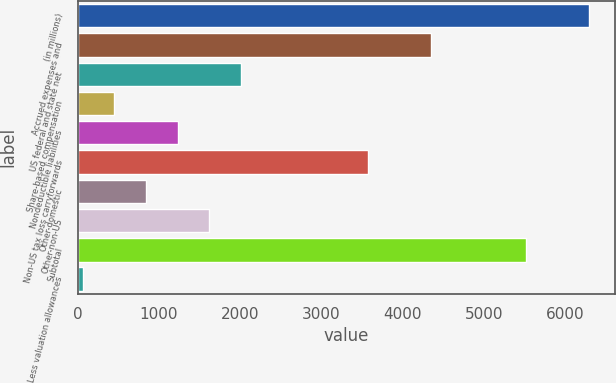Convert chart to OTSL. <chart><loc_0><loc_0><loc_500><loc_500><bar_chart><fcel>(in millions)<fcel>Accrued expenses and<fcel>US federal and state net<fcel>Share-based compensation<fcel>Nondeductible liabilities<fcel>Non-US tax loss carryforwards<fcel>Other-domestic<fcel>Other-non-US<fcel>Subtotal<fcel>Less valuation allowances<nl><fcel>6288<fcel>4343<fcel>2009<fcel>453<fcel>1231<fcel>3565<fcel>842<fcel>1620<fcel>5510<fcel>64<nl></chart> 